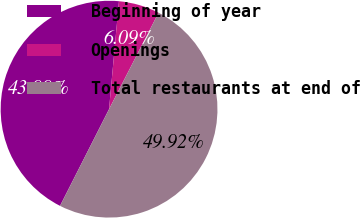<chart> <loc_0><loc_0><loc_500><loc_500><pie_chart><fcel>Beginning of year<fcel>Openings<fcel>Total restaurants at end of<nl><fcel>43.99%<fcel>6.09%<fcel>49.92%<nl></chart> 